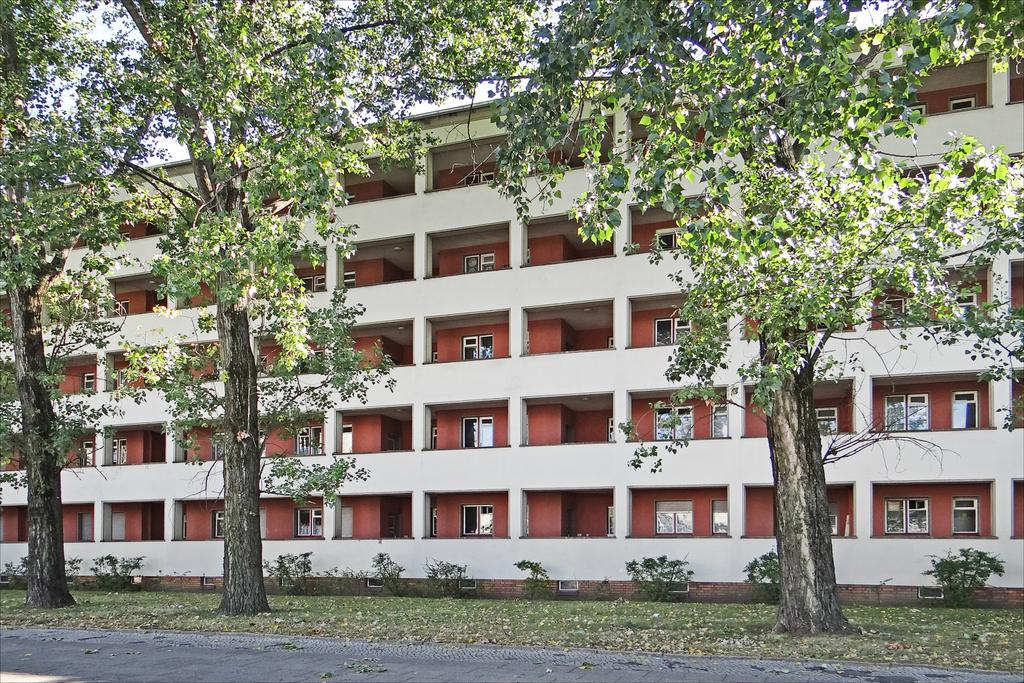What type of structure is present in the image? There is a building in the image. What architectural features can be seen on the building? The building has windows and pillars. What type of vegetation is present in the image? There are plants, trees, and grass in the image. Is there a designated walking area in the image? Yes, there is a pathway in the image. What part of the natural environment is visible in the image? The sky is visible in the image. What type of drink is being served in the clock tower in the image? There is no clock tower or drink present in the image. 